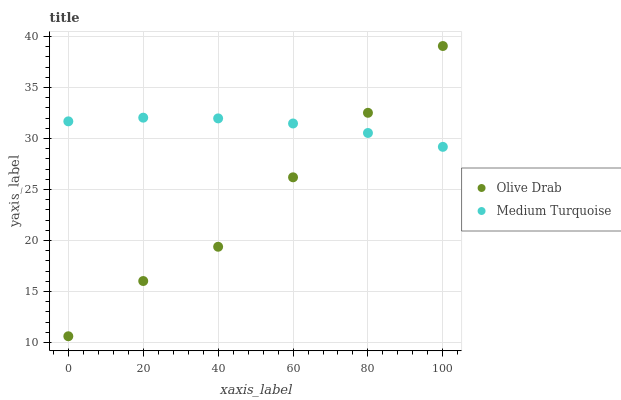Does Olive Drab have the minimum area under the curve?
Answer yes or no. Yes. Does Medium Turquoise have the maximum area under the curve?
Answer yes or no. Yes. Does Olive Drab have the maximum area under the curve?
Answer yes or no. No. Is Medium Turquoise the smoothest?
Answer yes or no. Yes. Is Olive Drab the roughest?
Answer yes or no. Yes. Is Olive Drab the smoothest?
Answer yes or no. No. Does Olive Drab have the lowest value?
Answer yes or no. Yes. Does Olive Drab have the highest value?
Answer yes or no. Yes. Does Medium Turquoise intersect Olive Drab?
Answer yes or no. Yes. Is Medium Turquoise less than Olive Drab?
Answer yes or no. No. Is Medium Turquoise greater than Olive Drab?
Answer yes or no. No. 